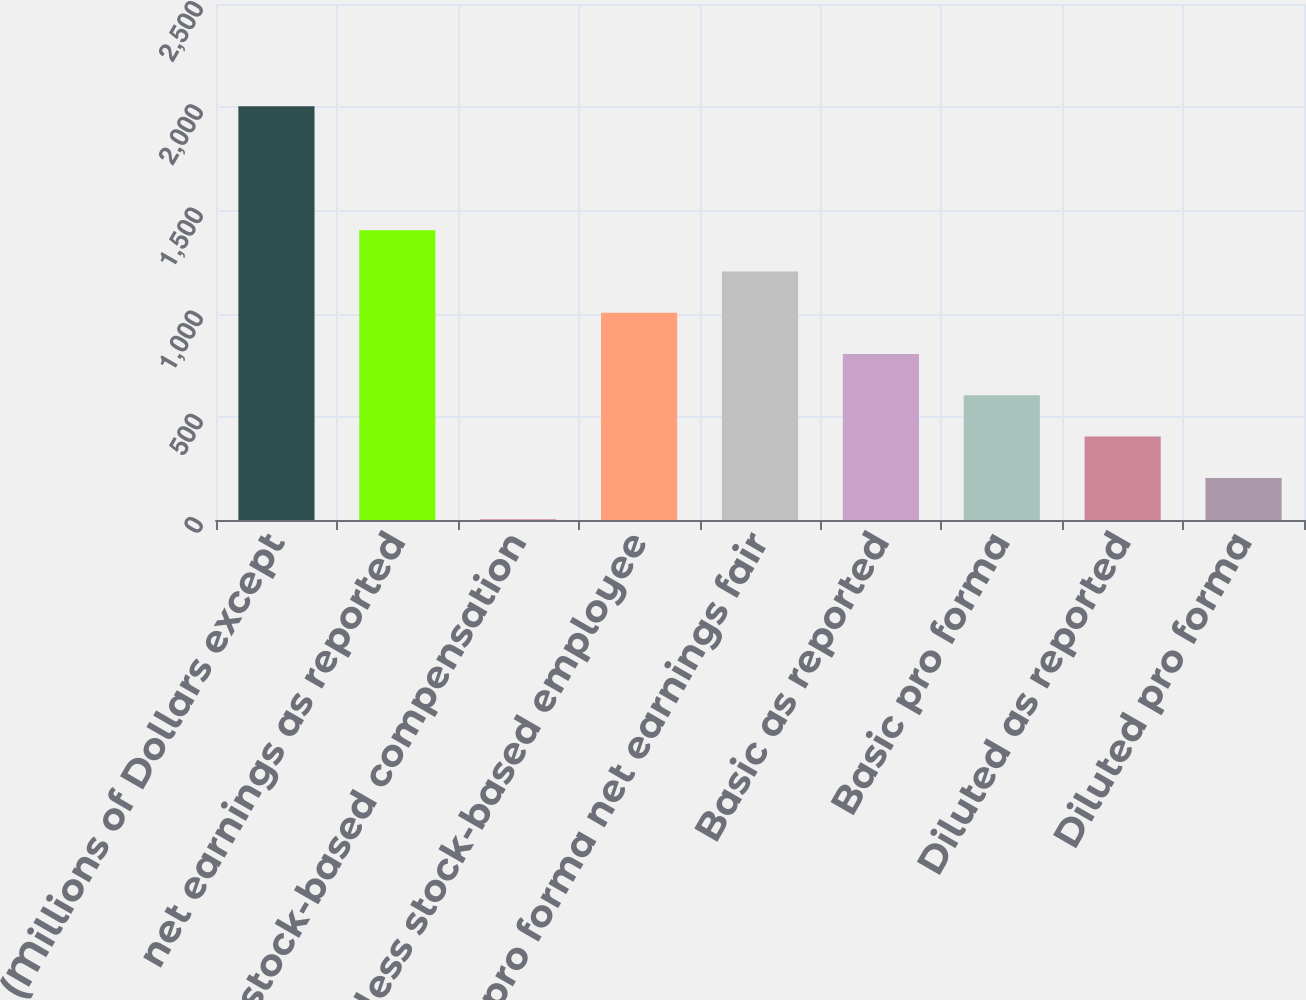Convert chart to OTSL. <chart><loc_0><loc_0><loc_500><loc_500><bar_chart><fcel>(Millions of Dollars except<fcel>net earnings as reported<fcel>Add stock-based compensation<fcel>less stock-based employee<fcel>pro forma net earnings fair<fcel>Basic as reported<fcel>Basic pro forma<fcel>Diluted as reported<fcel>Diluted pro forma<nl><fcel>2004<fcel>1404.03<fcel>4.1<fcel>1004.05<fcel>1204.04<fcel>804.06<fcel>604.07<fcel>404.08<fcel>204.09<nl></chart> 